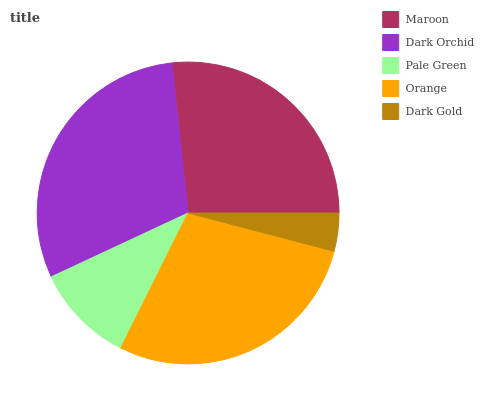Is Dark Gold the minimum?
Answer yes or no. Yes. Is Dark Orchid the maximum?
Answer yes or no. Yes. Is Pale Green the minimum?
Answer yes or no. No. Is Pale Green the maximum?
Answer yes or no. No. Is Dark Orchid greater than Pale Green?
Answer yes or no. Yes. Is Pale Green less than Dark Orchid?
Answer yes or no. Yes. Is Pale Green greater than Dark Orchid?
Answer yes or no. No. Is Dark Orchid less than Pale Green?
Answer yes or no. No. Is Maroon the high median?
Answer yes or no. Yes. Is Maroon the low median?
Answer yes or no. Yes. Is Dark Gold the high median?
Answer yes or no. No. Is Orange the low median?
Answer yes or no. No. 